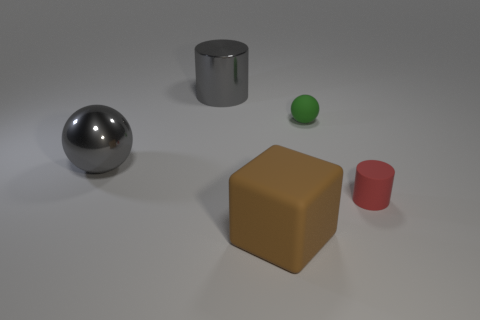Add 2 brown rubber objects. How many objects exist? 7 Subtract all matte cylinders. Subtract all large blocks. How many objects are left? 3 Add 2 matte blocks. How many matte blocks are left? 3 Add 5 large objects. How many large objects exist? 8 Subtract 0 brown cylinders. How many objects are left? 5 Subtract all cylinders. How many objects are left? 3 